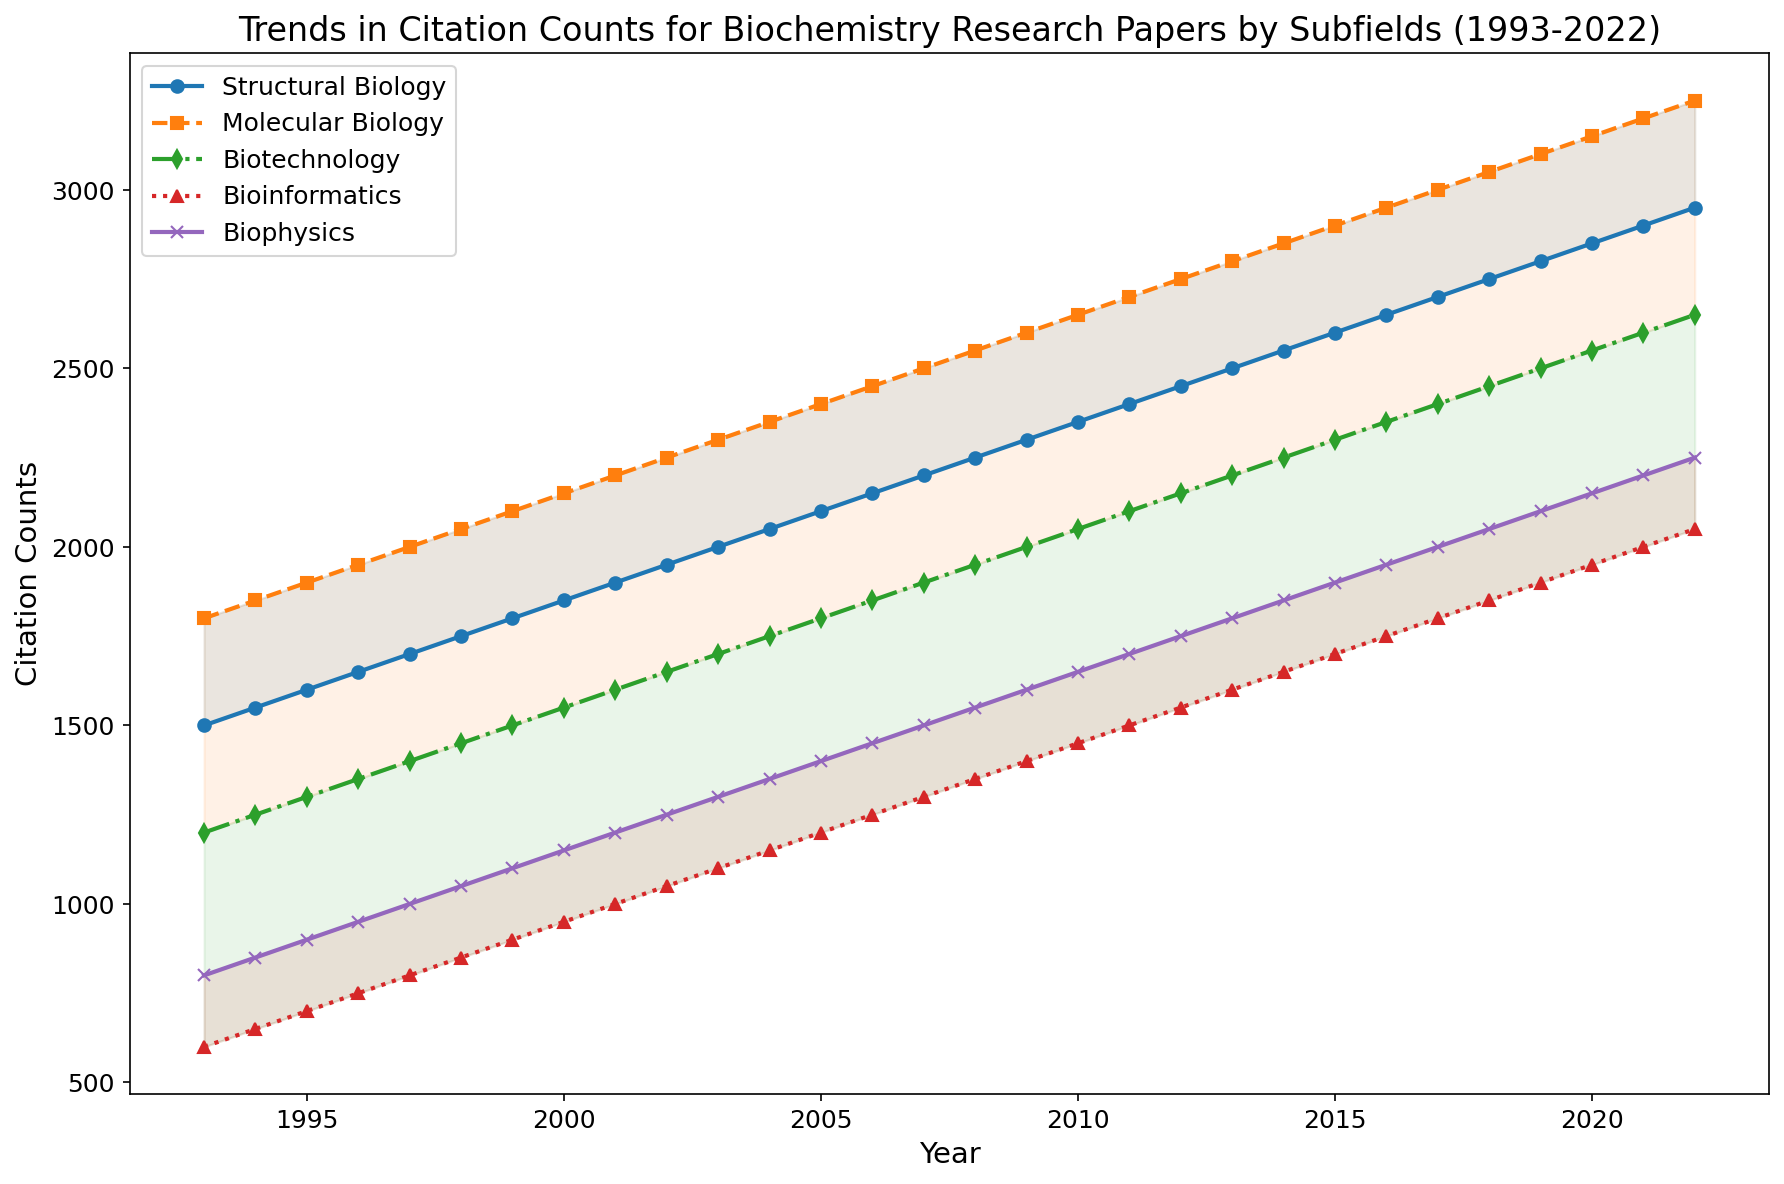Which subfield shows the highest overall citation count in 2022? By looking at the end points of the lines on the right side of the chart, you can see that "Molecular Biology" has the highest citation count reaching close to 3250.
Answer: Molecular Biology How has the citation count for Bioinformatics changed from 1993 to 2022? In 1993, Bioinformatics had around 600 citations. This count steadily increased each year, reaching approximately 2000 citations by 2022. Therefore, it shows a significant upward trend in the citation count over 30 years.
Answer: Increased significantly Which subfield experienced the highest rate of increase in citation counts over the 30 years? By comparing the slopes of the lines, "Bioinformatics" appears to have had the steepest increase in citation counts, indicating it experienced the highest rate of increase over the period.
Answer: Bioinformatics Between 2000 and 2010, which subfield's citation count increased the most? By observing the lines, "Molecular Biology" had an increase from roughly 2150 in 2000 to about 2650 in 2010, an increase of 500 citations. This is the highest increase among all subfields over this period.
Answer: Molecular Biology In which year did "Structural Biology" and "Molecular Biology" reach a citation count of approximately 2000? By following the trend lines up to the point where they cross the 2000 citation count line on the y-axis, "Structural Biology" reached this milestone around 1997, and "Molecular Biology" around 2000.
Answer: 1997 and 2000 What is the difference in citation counts between "Biotechnology" and "Biophysics" in 2022? In 2022, "Biotechnology" had a citation count of around 2650, while "Biophysics" had around 2250. The difference is 2650 - 2250 = 400.
Answer: 400 Which two subfields show the smallest difference in citation counts in the year 2005? By examining the gaps between the lines at the year 2005, "Structural Biology" and "Molecular Biology" have the smallest gap, both being very close around the 2400 citation count.
Answer: Structural Biology and Molecular Biology How does the visualization help in understanding the trends in citation counts? The lines and filled areas between them make it easier to see trends and compare citation counts across different subfields over the 30-year period. The colors and fills highlight the magnitude of differences and overlapping trends.
Answer: Easier trend comparison Is there ever any crossover between the citation counts of "Bioinformatics" and "Biophysics" within the shown period? By tracing the lines for "Bioinformatics" and "Biophysics," they do not cross each other at any point from 1993 to 2022.
Answer: No What is the average annual increase in citation counts for "Biotechnology" from 1993 to 2022? The citation count for "Biotechnology" in 1993 is around 1200 and in 2022 it is 2650. The total increase is 2650 - 1200 = 1450 over 30 years. The average annual increase is 1450 / 30 = 48.33.
Answer: 48.33 